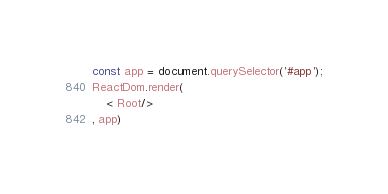<code> <loc_0><loc_0><loc_500><loc_500><_JavaScript_>const app = document.querySelector('#app');
ReactDom.render(
    < Root/>
, app)</code> 